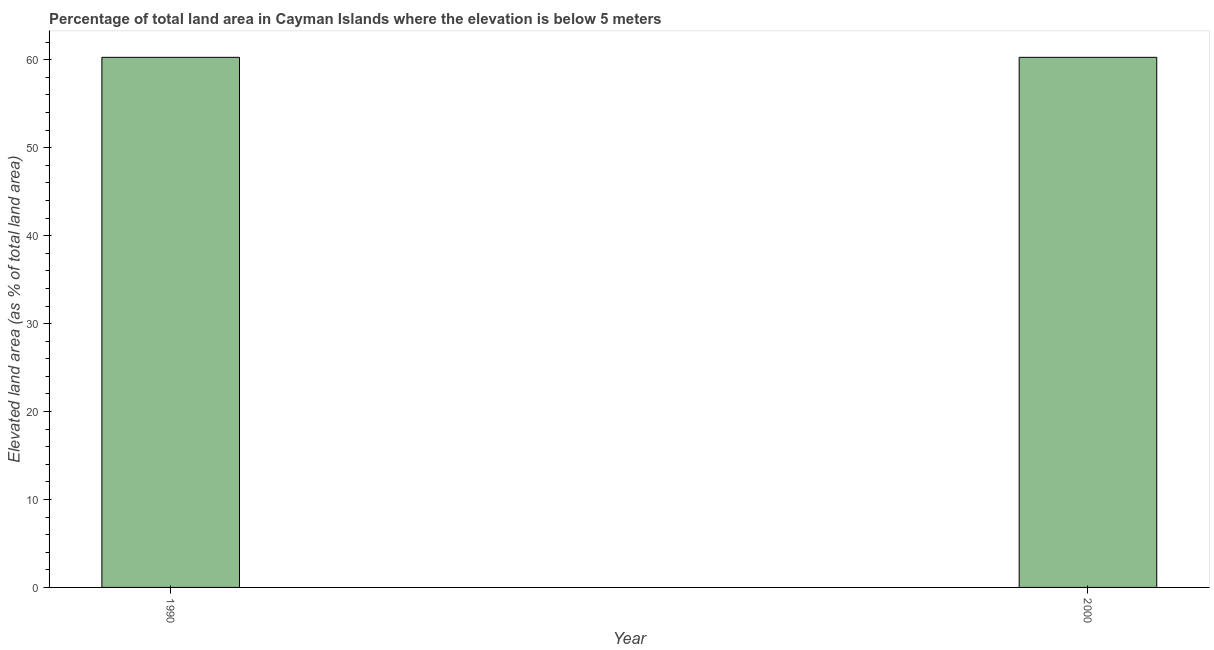Does the graph contain grids?
Provide a short and direct response. No. What is the title of the graph?
Offer a terse response. Percentage of total land area in Cayman Islands where the elevation is below 5 meters. What is the label or title of the X-axis?
Your answer should be very brief. Year. What is the label or title of the Y-axis?
Offer a terse response. Elevated land area (as % of total land area). What is the total elevated land area in 2000?
Your response must be concise. 60.28. Across all years, what is the maximum total elevated land area?
Your response must be concise. 60.28. Across all years, what is the minimum total elevated land area?
Offer a very short reply. 60.28. In which year was the total elevated land area minimum?
Your answer should be very brief. 1990. What is the sum of the total elevated land area?
Your answer should be very brief. 120.57. What is the average total elevated land area per year?
Your answer should be compact. 60.28. What is the median total elevated land area?
Offer a very short reply. 60.28. Do a majority of the years between 1990 and 2000 (inclusive) have total elevated land area greater than 40 %?
Provide a short and direct response. Yes. Is the total elevated land area in 1990 less than that in 2000?
Offer a terse response. No. In how many years, is the total elevated land area greater than the average total elevated land area taken over all years?
Provide a short and direct response. 0. How many bars are there?
Your response must be concise. 2. Are all the bars in the graph horizontal?
Keep it short and to the point. No. How many years are there in the graph?
Offer a very short reply. 2. What is the difference between two consecutive major ticks on the Y-axis?
Your answer should be compact. 10. Are the values on the major ticks of Y-axis written in scientific E-notation?
Offer a terse response. No. What is the Elevated land area (as % of total land area) in 1990?
Your answer should be very brief. 60.28. What is the Elevated land area (as % of total land area) in 2000?
Ensure brevity in your answer.  60.28. What is the difference between the Elevated land area (as % of total land area) in 1990 and 2000?
Make the answer very short. 0. What is the ratio of the Elevated land area (as % of total land area) in 1990 to that in 2000?
Your response must be concise. 1. 